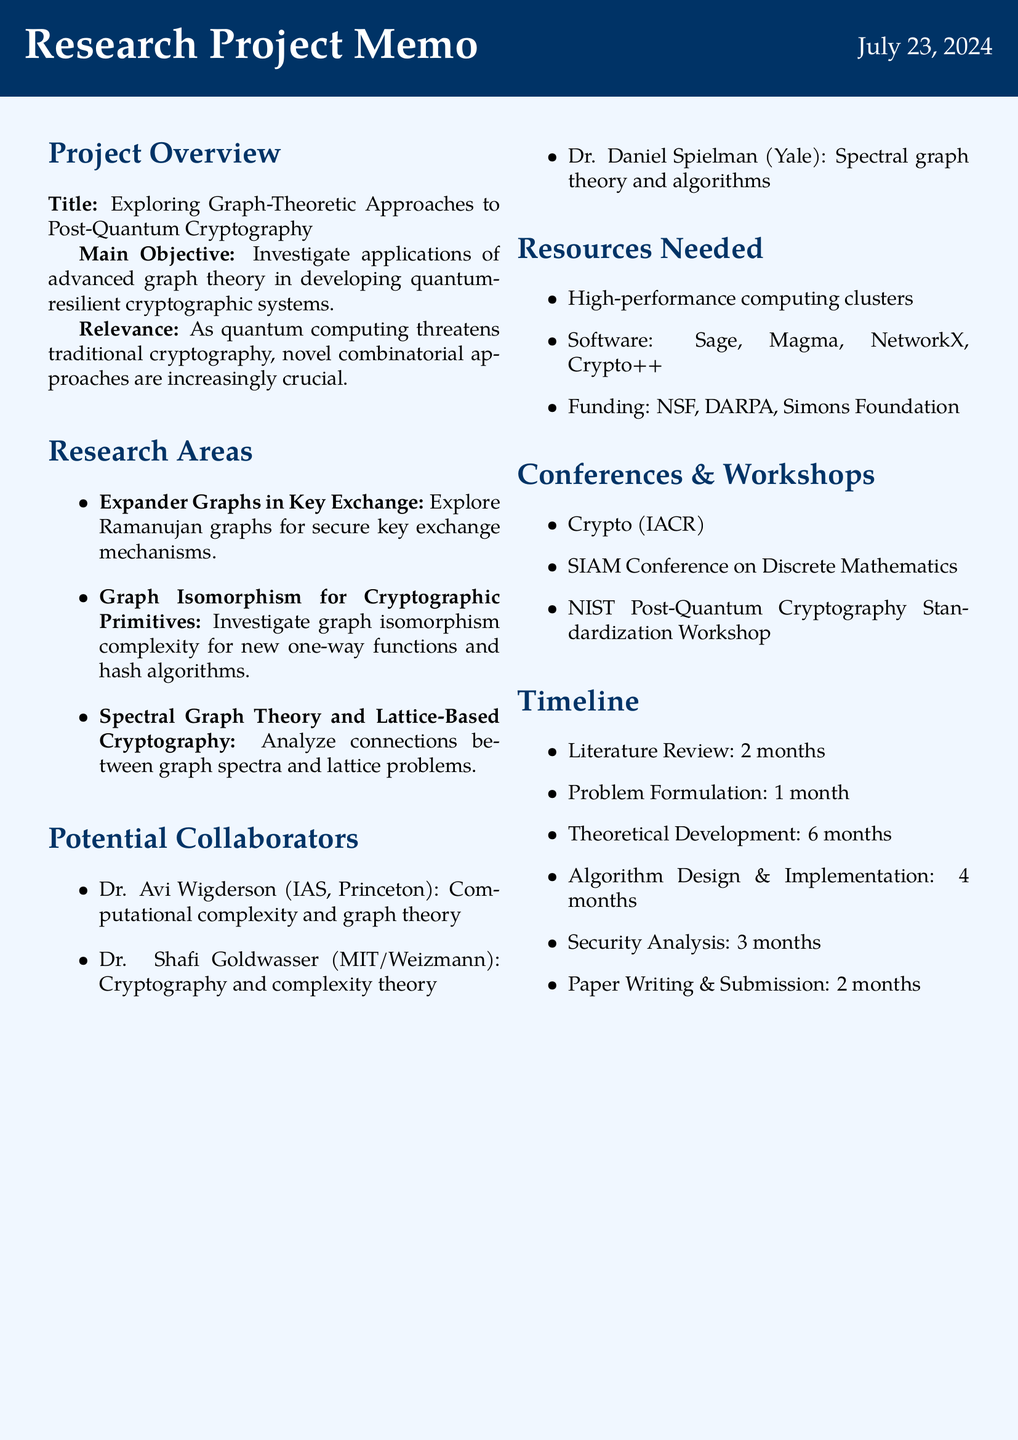What is the project title? The project title is explicitly stated in the document under Project Overview.
Answer: Exploring Graph-Theoretic Approaches to Post-Quantum Cryptography How many months are allocated for the literature review? The timeline section specifies the duration allocated for the literature review.
Answer: 2 months Who is a potential collaborator with expertise in cryptography? The document lists potential collaborators along with their expertise in different fields.
Answer: Dr. Shafi Goldwasser What type of resources are needed for the project? The resources section provides a list of types of resources necessary for the project's success.
Answer: Computational Resources What is the main objective of the project? The main objective is outlined in the Project Overview section and describes the central aim of the research.
Answer: Investigate applications of advanced graph theory in developing quantum-resilient cryptographic systems How many months is the theoretical development phase? The timeline provides details on the duration for each phase of the project, including theoretical development.
Answer: 6 months Which conference is organized by IACR? The list of conferences includes the name and organizing body of significant conferences related to the project.
Answer: Crypto What is the potential impact of using expander graphs in key exchange? The potential impact is described in the research areas, illustrating the significance of the research topic.
Answer: Improved efficiency and security in post-quantum key distribution systems Which potential source is listed for funding? The resources needed section outlines potential sources for funding, including organizations that may provide financial support.
Answer: National Science Foundation (NSF) 